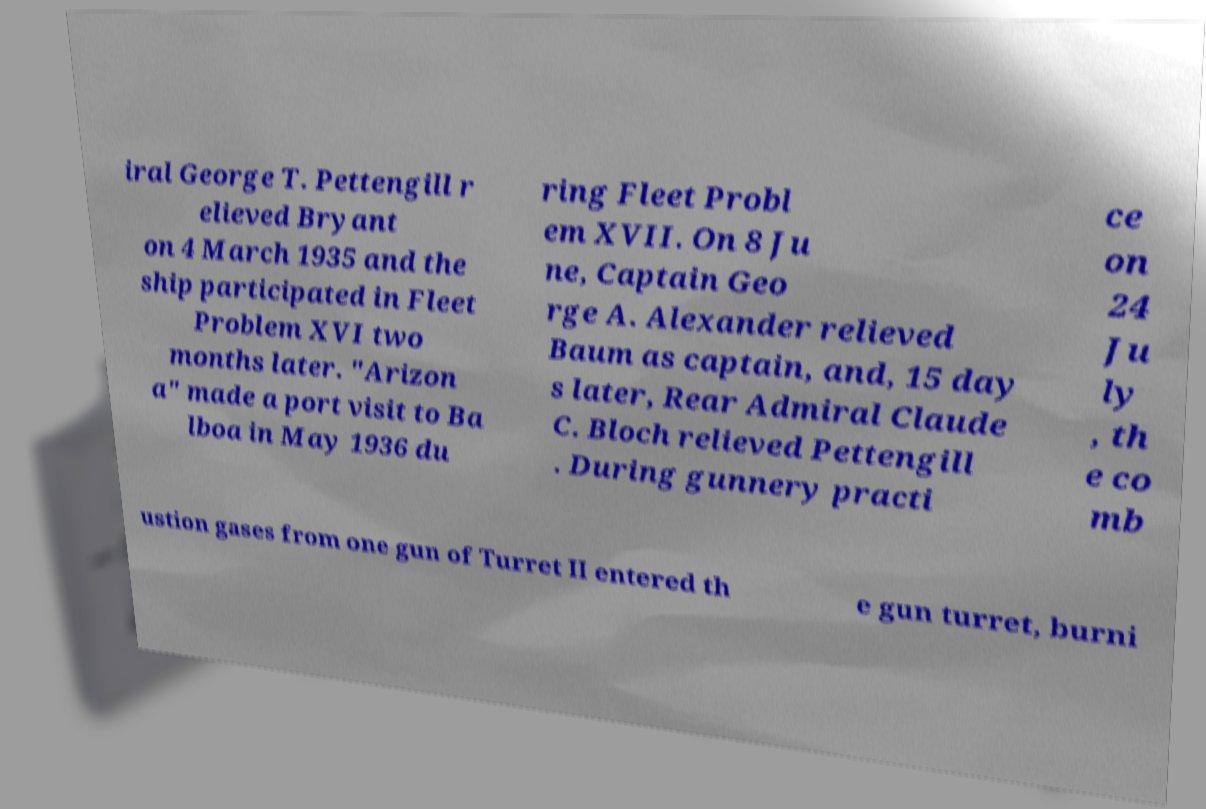What messages or text are displayed in this image? I need them in a readable, typed format. iral George T. Pettengill r elieved Bryant on 4 March 1935 and the ship participated in Fleet Problem XVI two months later. "Arizon a" made a port visit to Ba lboa in May 1936 du ring Fleet Probl em XVII. On 8 Ju ne, Captain Geo rge A. Alexander relieved Baum as captain, and, 15 day s later, Rear Admiral Claude C. Bloch relieved Pettengill . During gunnery practi ce on 24 Ju ly , th e co mb ustion gases from one gun of Turret II entered th e gun turret, burni 